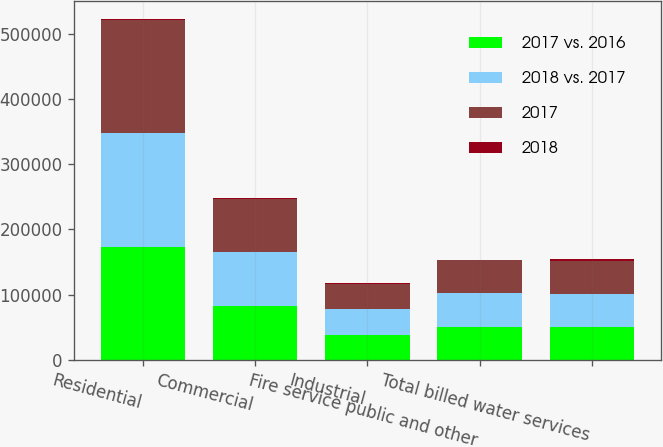Convert chart. <chart><loc_0><loc_0><loc_500><loc_500><stacked_bar_chart><ecel><fcel>Residential<fcel>Commercial<fcel>Industrial<fcel>Fire service public and other<fcel>Total billed water services<nl><fcel>2017 vs. 2016<fcel>172827<fcel>82572<fcel>38432<fcel>50651<fcel>50651<nl><fcel>2018 vs. 2017<fcel>174420<fcel>82147<fcel>39404<fcel>51341<fcel>50651<nl><fcel>2017<fcel>174599<fcel>82489<fcel>38465<fcel>50678<fcel>50651<nl><fcel>2018<fcel>1593<fcel>425<fcel>972<fcel>690<fcel>2830<nl></chart> 